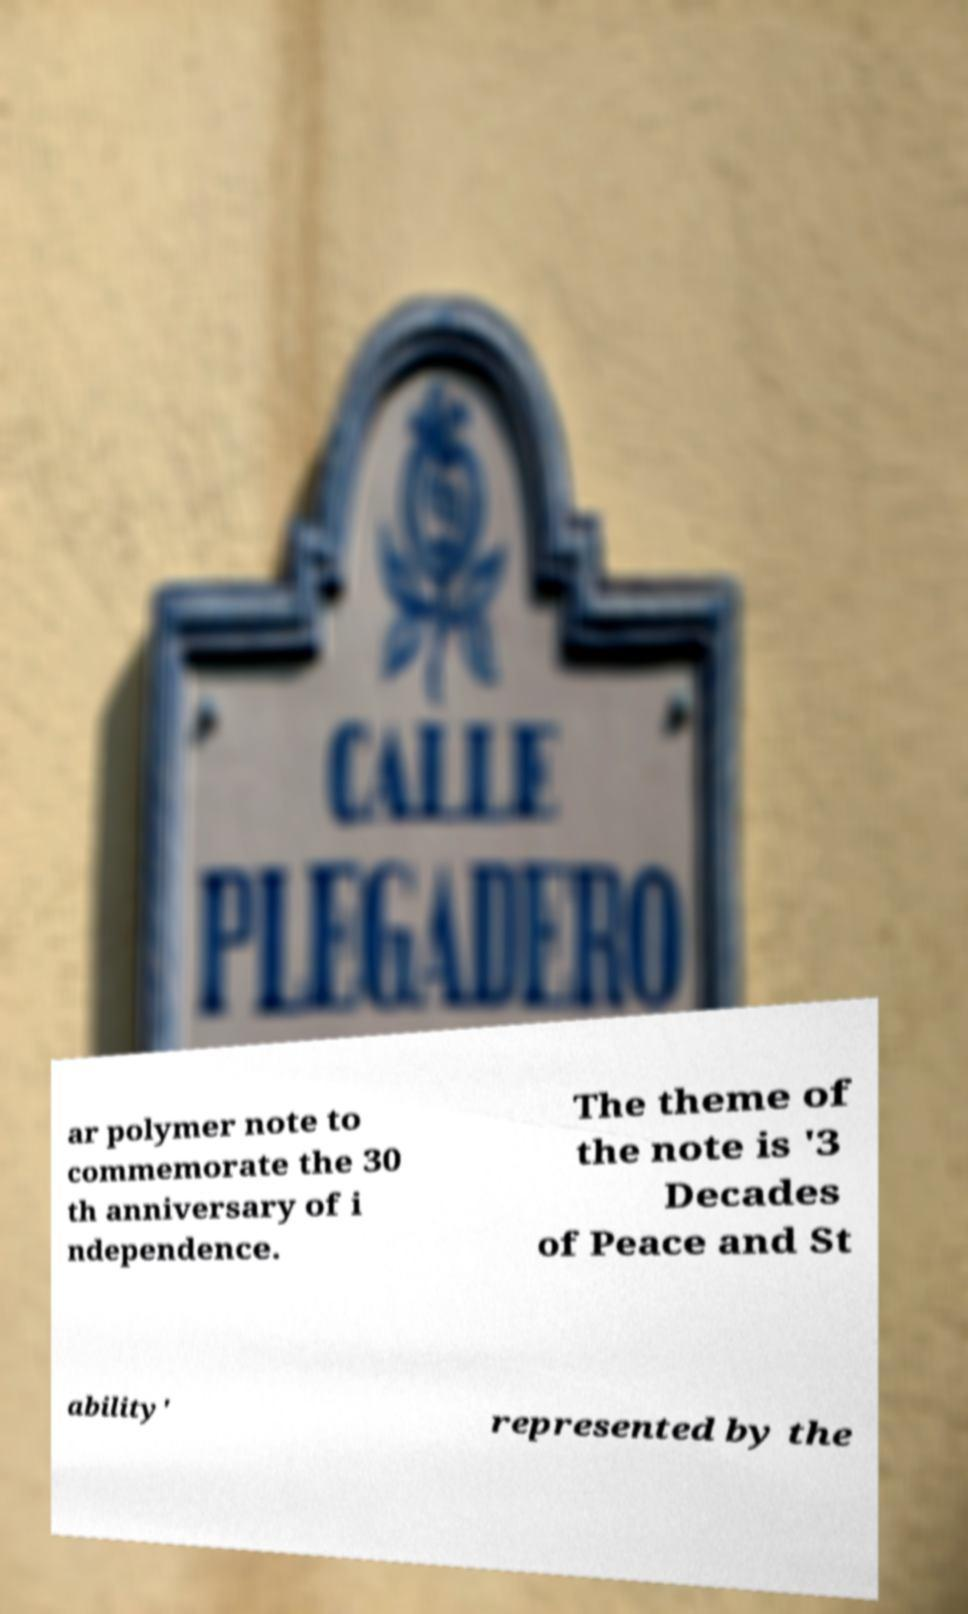Please identify and transcribe the text found in this image. ar polymer note to commemorate the 30 th anniversary of i ndependence. The theme of the note is '3 Decades of Peace and St ability' represented by the 